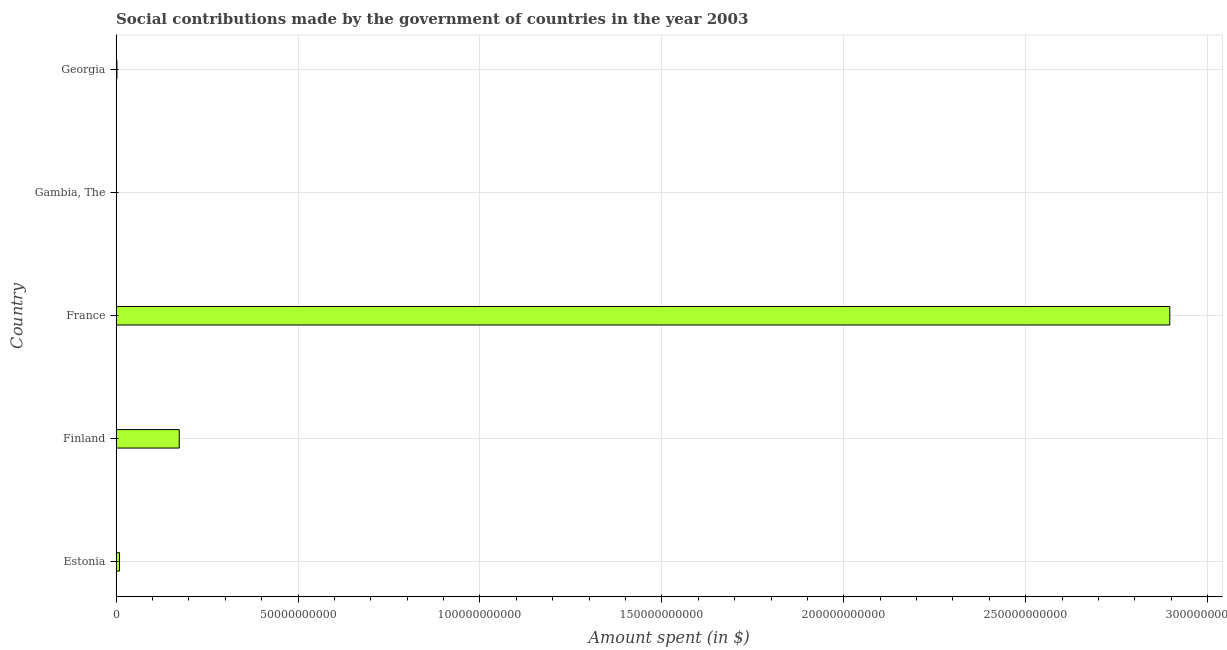Does the graph contain any zero values?
Keep it short and to the point. No. What is the title of the graph?
Make the answer very short. Social contributions made by the government of countries in the year 2003. What is the label or title of the X-axis?
Your answer should be very brief. Amount spent (in $). What is the amount spent in making social contributions in Gambia, The?
Your answer should be compact. 3.30e+06. Across all countries, what is the maximum amount spent in making social contributions?
Keep it short and to the point. 2.90e+11. Across all countries, what is the minimum amount spent in making social contributions?
Offer a terse response. 3.30e+06. In which country was the amount spent in making social contributions minimum?
Offer a very short reply. Gambia, The. What is the sum of the amount spent in making social contributions?
Your answer should be very brief. 3.08e+11. What is the difference between the amount spent in making social contributions in Finland and Georgia?
Provide a short and direct response. 1.71e+1. What is the average amount spent in making social contributions per country?
Your answer should be compact. 6.16e+1. What is the median amount spent in making social contributions?
Make the answer very short. 9.30e+08. In how many countries, is the amount spent in making social contributions greater than 160000000000 $?
Ensure brevity in your answer.  1. What is the ratio of the amount spent in making social contributions in Estonia to that in Finland?
Provide a short and direct response. 0.05. Is the amount spent in making social contributions in Finland less than that in Georgia?
Offer a very short reply. No. Is the difference between the amount spent in making social contributions in Finland and France greater than the difference between any two countries?
Provide a succinct answer. No. What is the difference between the highest and the second highest amount spent in making social contributions?
Keep it short and to the point. 2.72e+11. Is the sum of the amount spent in making social contributions in Finland and Georgia greater than the maximum amount spent in making social contributions across all countries?
Your answer should be compact. No. What is the difference between the highest and the lowest amount spent in making social contributions?
Offer a terse response. 2.90e+11. In how many countries, is the amount spent in making social contributions greater than the average amount spent in making social contributions taken over all countries?
Ensure brevity in your answer.  1. Are all the bars in the graph horizontal?
Give a very brief answer. Yes. How many countries are there in the graph?
Your answer should be compact. 5. What is the Amount spent (in $) in Estonia?
Ensure brevity in your answer.  9.30e+08. What is the Amount spent (in $) in Finland?
Offer a terse response. 1.74e+1. What is the Amount spent (in $) in France?
Your answer should be compact. 2.90e+11. What is the Amount spent (in $) in Gambia, The?
Offer a very short reply. 3.30e+06. What is the Amount spent (in $) of Georgia?
Make the answer very short. 2.23e+08. What is the difference between the Amount spent (in $) in Estonia and Finland?
Provide a succinct answer. -1.64e+1. What is the difference between the Amount spent (in $) in Estonia and France?
Make the answer very short. -2.89e+11. What is the difference between the Amount spent (in $) in Estonia and Gambia, The?
Give a very brief answer. 9.27e+08. What is the difference between the Amount spent (in $) in Estonia and Georgia?
Make the answer very short. 7.08e+08. What is the difference between the Amount spent (in $) in Finland and France?
Your answer should be very brief. -2.72e+11. What is the difference between the Amount spent (in $) in Finland and Gambia, The?
Offer a very short reply. 1.74e+1. What is the difference between the Amount spent (in $) in Finland and Georgia?
Provide a succinct answer. 1.71e+1. What is the difference between the Amount spent (in $) in France and Gambia, The?
Offer a terse response. 2.90e+11. What is the difference between the Amount spent (in $) in France and Georgia?
Make the answer very short. 2.89e+11. What is the difference between the Amount spent (in $) in Gambia, The and Georgia?
Provide a short and direct response. -2.19e+08. What is the ratio of the Amount spent (in $) in Estonia to that in Finland?
Offer a terse response. 0.05. What is the ratio of the Amount spent (in $) in Estonia to that in France?
Your response must be concise. 0. What is the ratio of the Amount spent (in $) in Estonia to that in Gambia, The?
Your answer should be compact. 281.88. What is the ratio of the Amount spent (in $) in Estonia to that in Georgia?
Offer a very short reply. 4.18. What is the ratio of the Amount spent (in $) in Finland to that in Gambia, The?
Keep it short and to the point. 5258.79. What is the ratio of the Amount spent (in $) in Finland to that in Georgia?
Your answer should be compact. 77.92. What is the ratio of the Amount spent (in $) in France to that in Gambia, The?
Your answer should be compact. 8.78e+04. What is the ratio of the Amount spent (in $) in France to that in Georgia?
Keep it short and to the point. 1300.47. What is the ratio of the Amount spent (in $) in Gambia, The to that in Georgia?
Give a very brief answer. 0.01. 